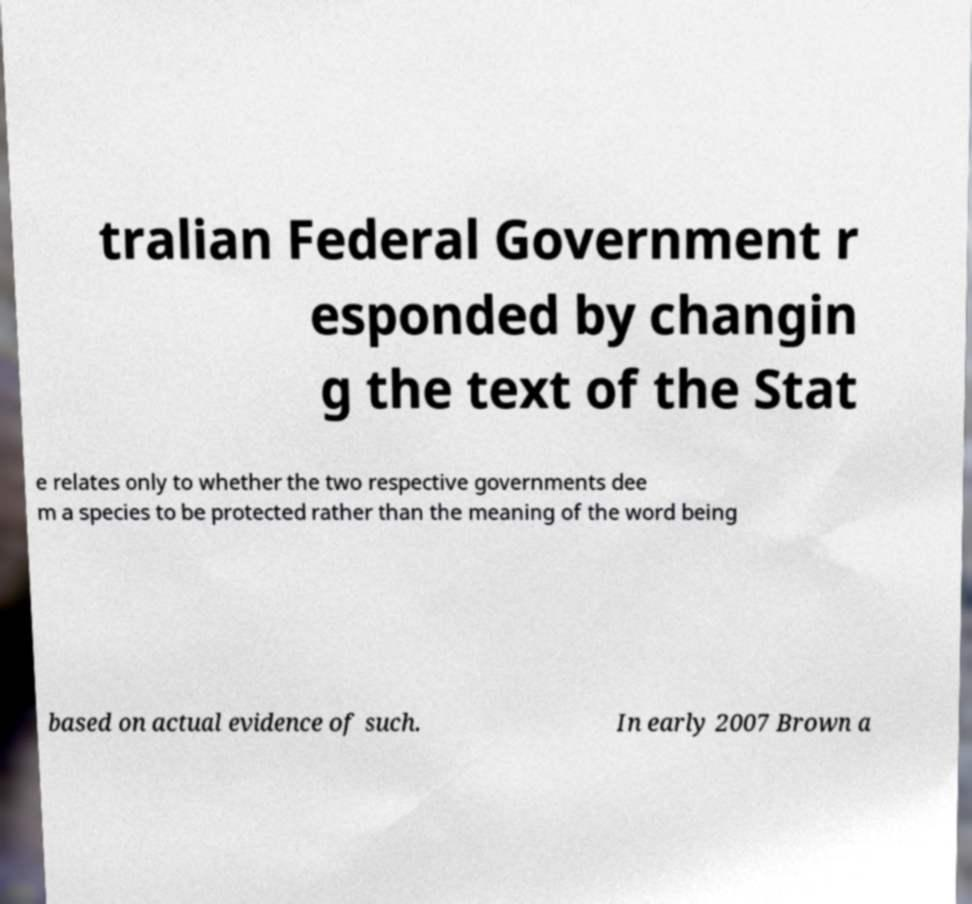Please read and relay the text visible in this image. What does it say? tralian Federal Government r esponded by changin g the text of the Stat e relates only to whether the two respective governments dee m a species to be protected rather than the meaning of the word being based on actual evidence of such. In early 2007 Brown a 